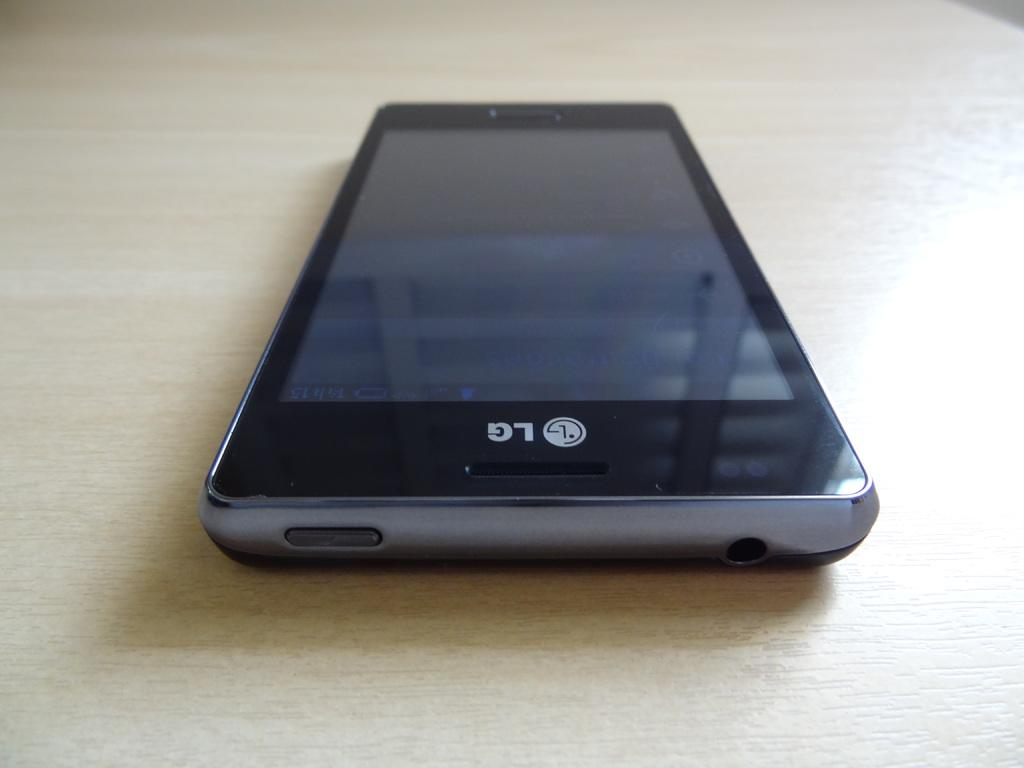<image>
Relay a brief, clear account of the picture shown. A LG phone sitting on a table that is turned off. 